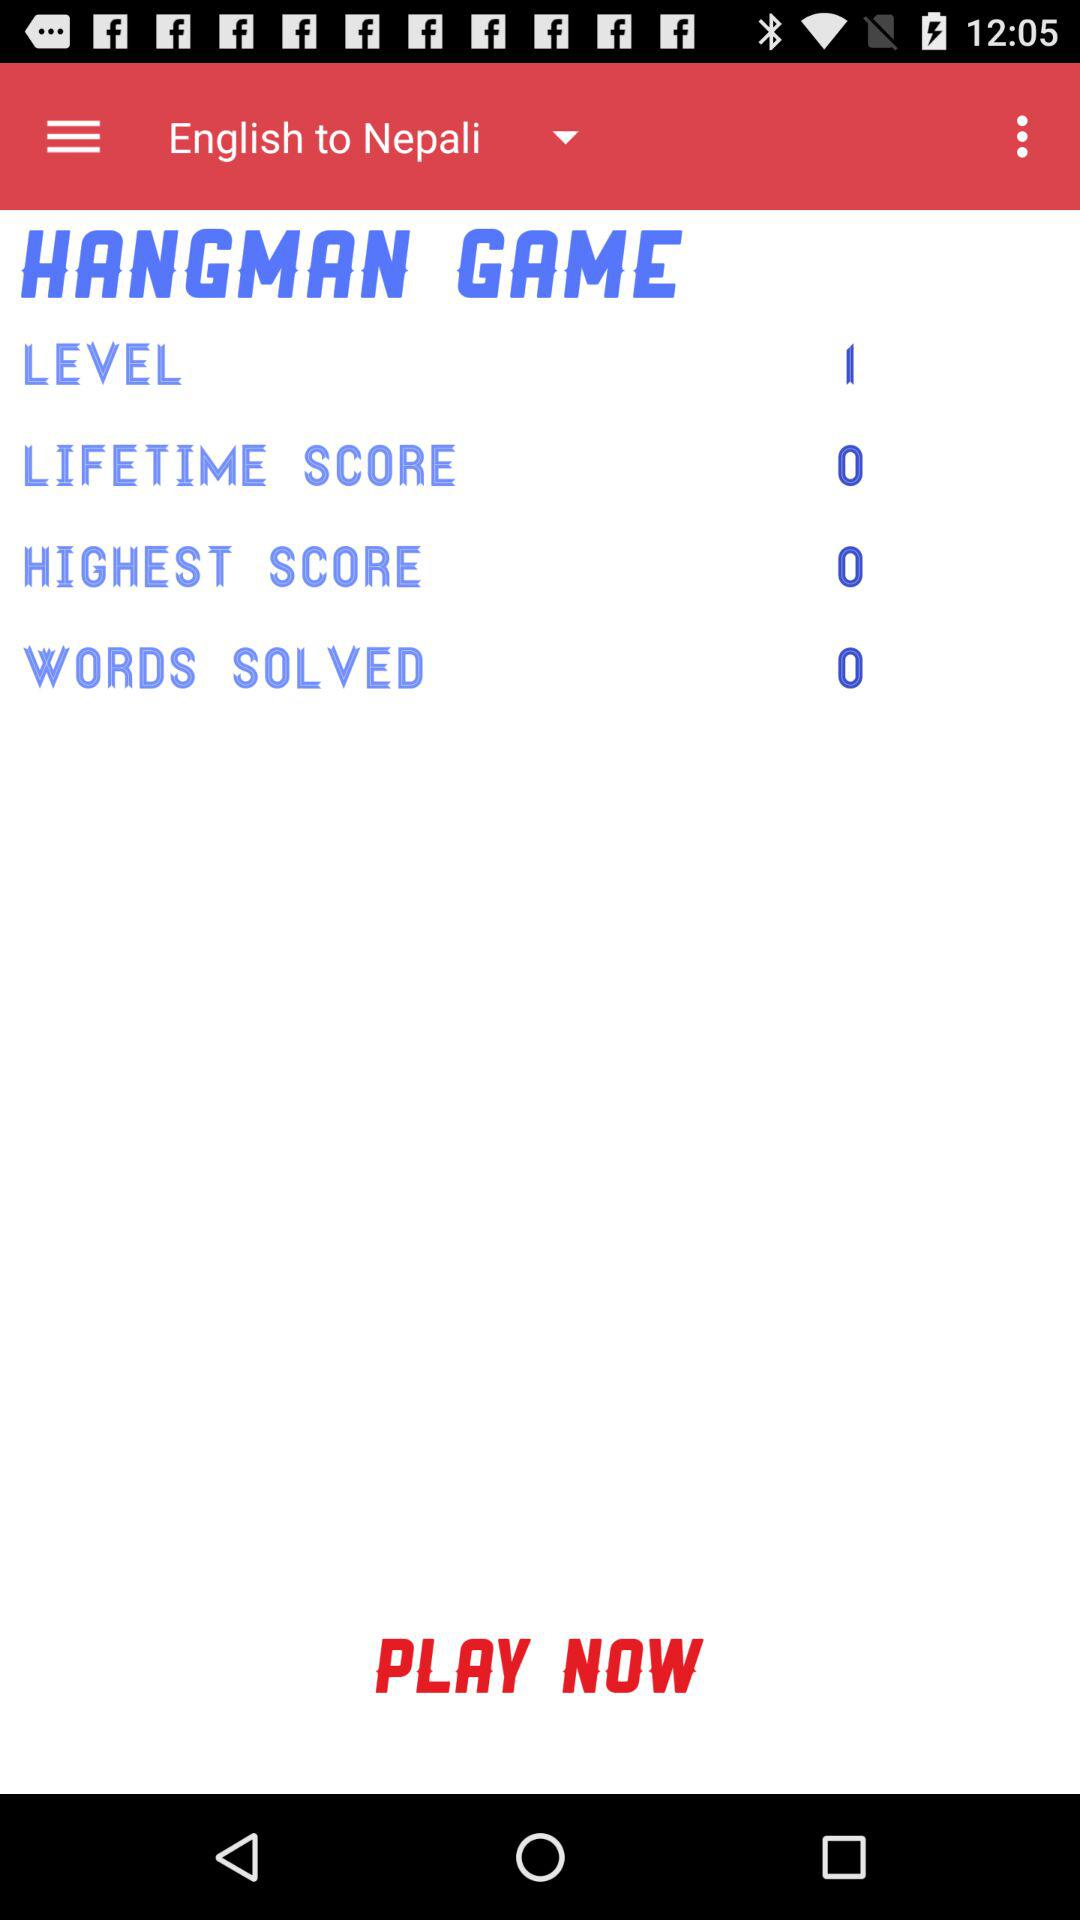What is the lifetime score? The lifetime score is 0. 